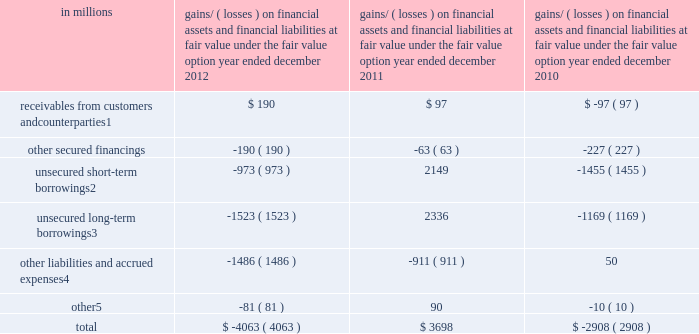Notes to consolidated financial statements gains and losses on financial assets and financial liabilities accounted for at fair value under the fair value option the table below presents the gains and losses recognized as a result of the firm electing to apply the fair value option to certain financial assets and financial liabilities .
These gains and losses are included in 201cmarket making 201d and 201cother principal transactions . 201d the table below also includes gains and losses on the embedded derivative component of hybrid financial instruments included in unsecured short-term borrowings and unsecured long-term borrowings .
These gains and losses would have been recognized under other u.s .
Gaap even if the firm had not elected to account for the entire hybrid instrument at fair value .
The amounts in the table exclude contractual interest , which is included in 201cinterest income 201d and 201cinterest expense , 201d for all instruments other than hybrid financial instruments .
See note 23 for further information about interest income and interest expense .
Gains/ ( losses ) on financial assets and financial liabilities at fair value under the fair value option year ended december in millions 2012 2011 2010 receivables from customers and counterparties 1 $ 190 $ 97 $ ( 97 ) .
Primarily consists of gains/ ( losses ) on certain reinsurance contracts and certain transfers accounted for as receivables rather than purchases .
Includes gains/ ( losses ) on the embedded derivative component of hybrid financial instruments of $ ( 814 ) million , $ 2.01 billion , and $ ( 1.49 ) billion as of december 2012 , december 2011 and december 2010 , respectively .
Includes gains/ ( losses ) on the embedded derivative component of hybrid financial instruments of $ ( 887 ) million , $ 1.80 billion and $ ( 1.32 ) billion as of december 2012 , december 2011 and december 2010 , respectively .
Primarily consists of gains/ ( losses ) on certain insurance contracts .
Primarily consists of gains/ ( losses ) on resale and repurchase agreements , securities borrowed and loaned and deposits .
Excluding the gains and losses on the instruments accounted for under the fair value option described above , 201cmarket making 201d and 201cother principal transactions 201d primarily represent gains and losses on 201cfinancial instruments owned , at fair value 201d and 201cfinancial instruments sold , but not yet purchased , at fair value . 201d 150 goldman sachs 2012 annual report .
By what amount is the total gains/ ( losses ) on financial assets and financial liabilities at fair value at 2017 different from 2016? 
Computations: (3698 - -2908)
Answer: 6606.0. 